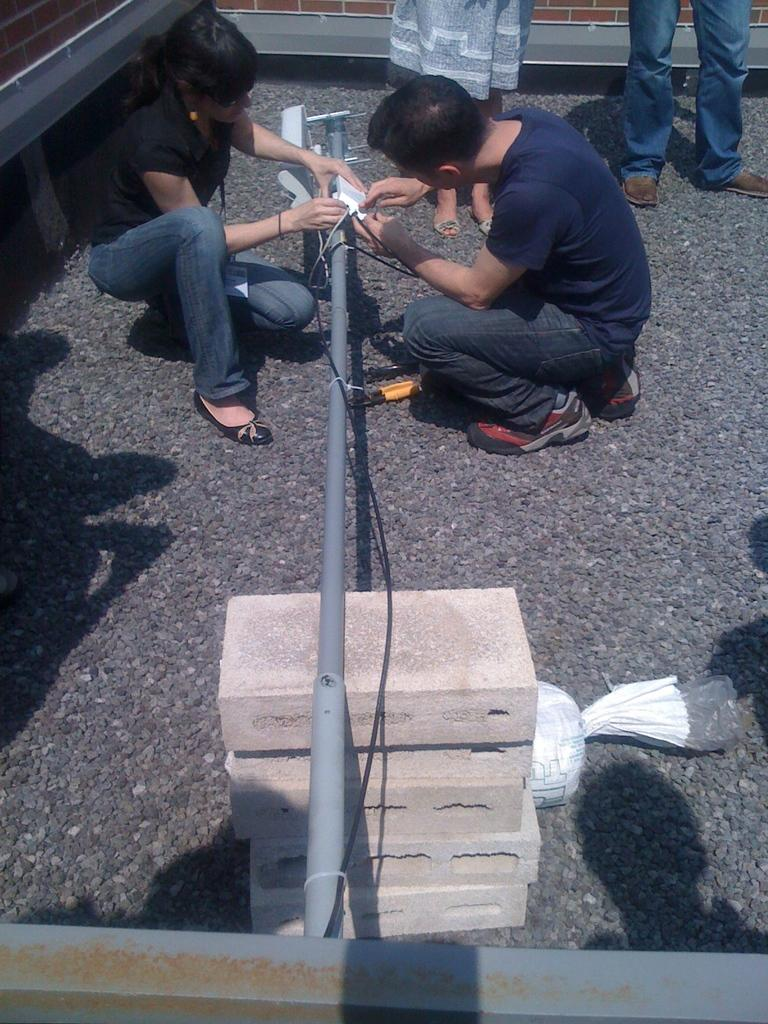What is the main object on the cement bricks in the image? There is a rod on cement bricks in the image. Are there any people in the image? Yes, there are people near the rod in the image. What part of the people's bodies can be seen? The people's legs are visible in the image. What are the people doing in the image? The two people are looking at the rod in the image. What type of ray can be seen swimming near the rod in the image? There is no ray present in the image; it features a rod on cement bricks and people looking at it. What kind of show is taking place near the rod in the image? There is no show present in the image; it features a rod on cement bricks and people looking at it. 